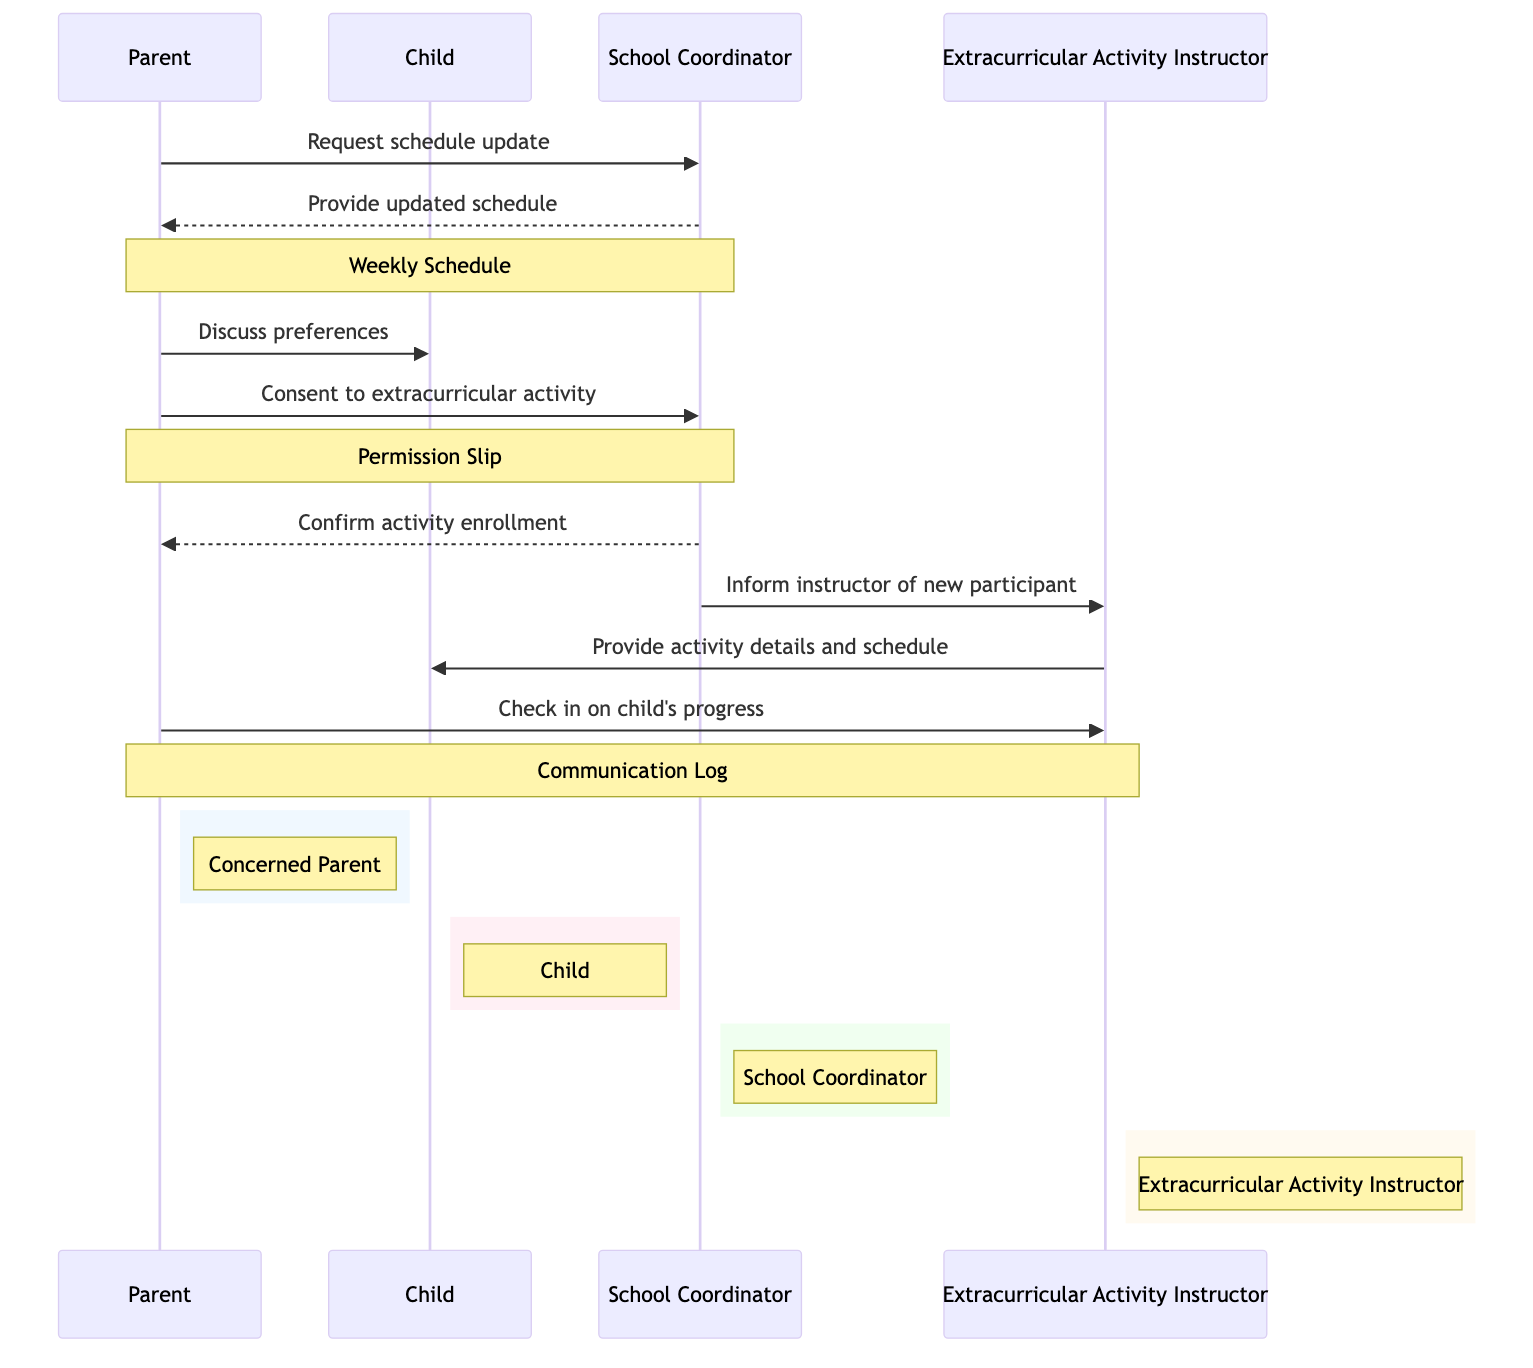What is the first message in the sequence? The first message in the sequence is sent from the Parent to the School Coordinator, where the Parent requests a schedule update.
Answer: Request schedule update How many actors are depicted in the diagram? The diagram has four actors: Parent, Child, School Coordinator, and Extracurricular Activity Instructor.
Answer: Four What object is associated with the message "Consent to extracurricular activity"? The object associated with this message is the Permission Slip. This is indicated by a note in the diagram.
Answer: Permission Slip Who does the School Coordinator confirm the activity enrollment to? The School Coordinator confirms the activity enrollment back to the Parent. This is shown by the directed message from the School Coordinator to the Parent.
Answer: Parent What does the Extracurricular Activity Instructor provide to the Child? The Extracurricular Activity Instructor provides activity details and schedule to the Child. This is indicated by the directed message from the instructor to the Child.
Answer: Activity details and schedule How many messages are exchanged between Parent and School Coordinator? There are three messages exchanged between the Parent and School Coordinator in the sequence. This includes the request for a schedule update, consent for the activity, and confirmation of enrollment.
Answer: Three Which message indicates the Parent's concern for the Child's progress? The message where the Parent checks in on the Child's progress indicates the concern. This is directed towards the Extracurricular Activity Instructor.
Answer: Check in on child's progress Which actor informs the Extracurricular Activity Instructor? The School Coordinator informs the Extracurricular Activity Instructor about the new participant, as depicted in the message flow directed from the School Coordinator to the instructor.
Answer: School Coordinator What does the note over School Coordinator and Parent represent? The note over the School Coordinator and Parent represents the Permission Slip, which indicates an important document in this process.
Answer: Permission Slip 